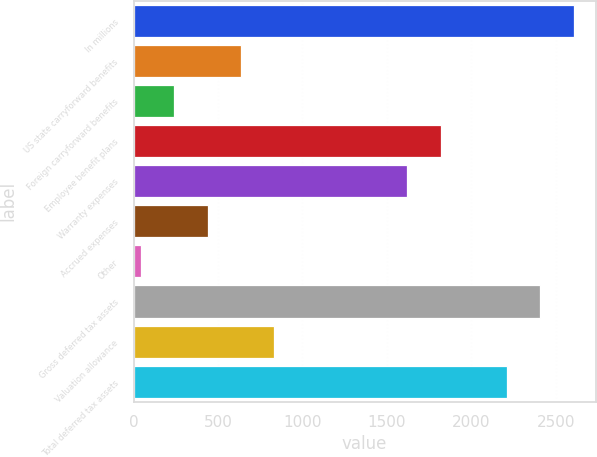<chart> <loc_0><loc_0><loc_500><loc_500><bar_chart><fcel>In millions<fcel>US state carryforward benefits<fcel>Foreign carryforward benefits<fcel>Employee benefit plans<fcel>Warranty expenses<fcel>Accrued expenses<fcel>Other<fcel>Gross deferred tax assets<fcel>Valuation allowance<fcel>Total deferred tax assets<nl><fcel>2604.7<fcel>635.7<fcel>241.9<fcel>1817.1<fcel>1620.2<fcel>438.8<fcel>45<fcel>2407.8<fcel>832.6<fcel>2210.9<nl></chart> 